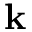<formula> <loc_0><loc_0><loc_500><loc_500>k</formula> 